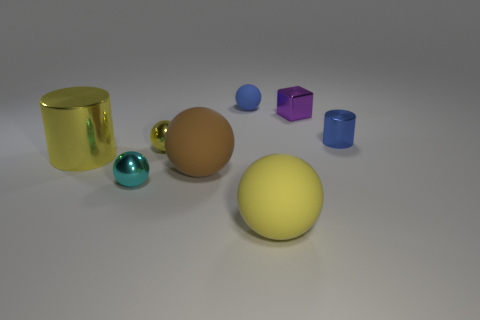How many metallic objects are both left of the small purple thing and to the right of the yellow metallic cylinder?
Give a very brief answer. 2. Is there a matte thing that has the same color as the large cylinder?
Give a very brief answer. Yes. There is a blue shiny thing that is the same size as the purple thing; what is its shape?
Offer a terse response. Cylinder. There is a small cyan ball; are there any matte spheres behind it?
Your answer should be very brief. Yes. Is the material of the ball that is to the right of the blue rubber sphere the same as the tiny sphere that is in front of the yellow cylinder?
Ensure brevity in your answer.  No. What number of metallic cubes are the same size as the blue rubber ball?
Provide a succinct answer. 1. What is the shape of the small shiny thing that is the same color as the big cylinder?
Provide a short and direct response. Sphere. There is a yellow thing to the right of the small yellow shiny thing; what material is it?
Your response must be concise. Rubber. What number of brown matte objects have the same shape as the yellow matte object?
Your answer should be compact. 1. The big object that is the same material as the small yellow ball is what shape?
Make the answer very short. Cylinder. 